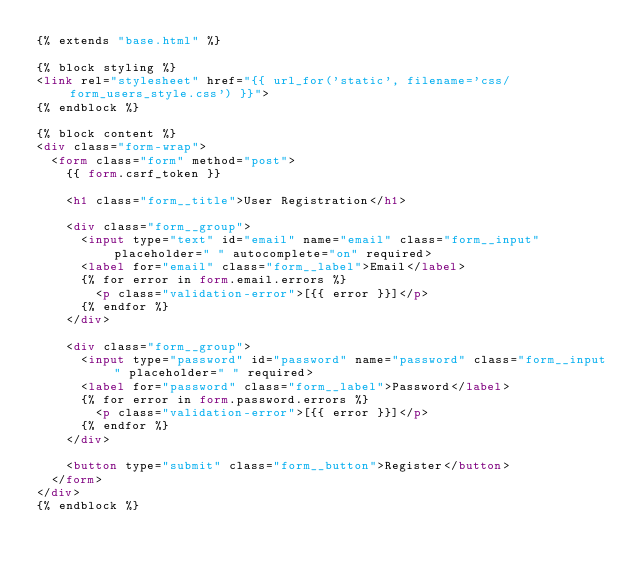<code> <loc_0><loc_0><loc_500><loc_500><_HTML_>{% extends "base.html" %}

{% block styling %}
<link rel="stylesheet" href="{{ url_for('static', filename='css/form_users_style.css') }}">
{% endblock %}

{% block content %}
<div class="form-wrap">
  <form class="form" method="post">
    {{ form.csrf_token }}

    <h1 class="form__title">User Registration</h1>

    <div class="form__group">
      <input type="text" id="email" name="email" class="form__input" placeholder=" " autocomplete="on" required>
      <label for="email" class="form__label">Email</label>
      {% for error in form.email.errors %}
        <p class="validation-error">[{{ error }}]</p>
      {% endfor %}
    </div>

    <div class="form__group">
      <input type="password" id="password" name="password" class="form__input" placeholder=" " required>
      <label for="password" class="form__label">Password</label>
      {% for error in form.password.errors %}
        <p class="validation-error">[{{ error }}]</p>
      {% endfor %}
    </div>

    <button type="submit" class="form__button">Register</button>
  </form>
</div>
{% endblock %}
</code> 